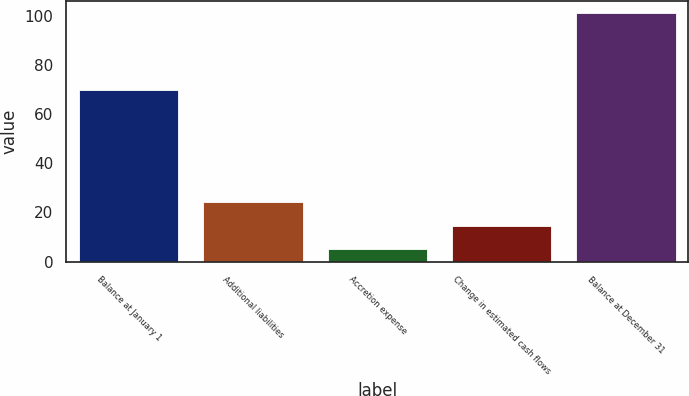<chart> <loc_0><loc_0><loc_500><loc_500><bar_chart><fcel>Balance at January 1<fcel>Additional liabilities<fcel>Accretion expense<fcel>Change in estimated cash flows<fcel>Balance at December 31<nl><fcel>70<fcel>24.2<fcel>5<fcel>14.6<fcel>101<nl></chart> 